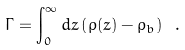<formula> <loc_0><loc_0><loc_500><loc_500>\Gamma = \int _ { 0 } ^ { \infty } d z \left ( \rho ( z ) - \rho _ { b } \right ) \ .</formula> 